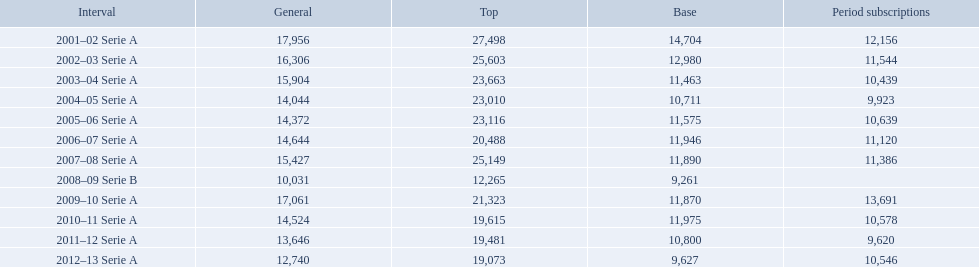What seasons were played at the stadio ennio tardini 2001–02 Serie A, 2002–03 Serie A, 2003–04 Serie A, 2004–05 Serie A, 2005–06 Serie A, 2006–07 Serie A, 2007–08 Serie A, 2008–09 Serie B, 2009–10 Serie A, 2010–11 Serie A, 2011–12 Serie A, 2012–13 Serie A. Which of these seasons had season tickets? 2001–02 Serie A, 2002–03 Serie A, 2003–04 Serie A, 2004–05 Serie A, 2005–06 Serie A, 2006–07 Serie A, 2007–08 Serie A, 2009–10 Serie A, 2010–11 Serie A, 2011–12 Serie A, 2012–13 Serie A. How many season tickets did the 2007-08 season have? 11,386. When were all of the seasons? 2001–02 Serie A, 2002–03 Serie A, 2003–04 Serie A, 2004–05 Serie A, 2005–06 Serie A, 2006–07 Serie A, 2007–08 Serie A, 2008–09 Serie B, 2009–10 Serie A, 2010–11 Serie A, 2011–12 Serie A, 2012–13 Serie A. How many tickets were sold? 12,156, 11,544, 10,439, 9,923, 10,639, 11,120, 11,386, , 13,691, 10,578, 9,620, 10,546. What about just during the 2007 season? 11,386. 